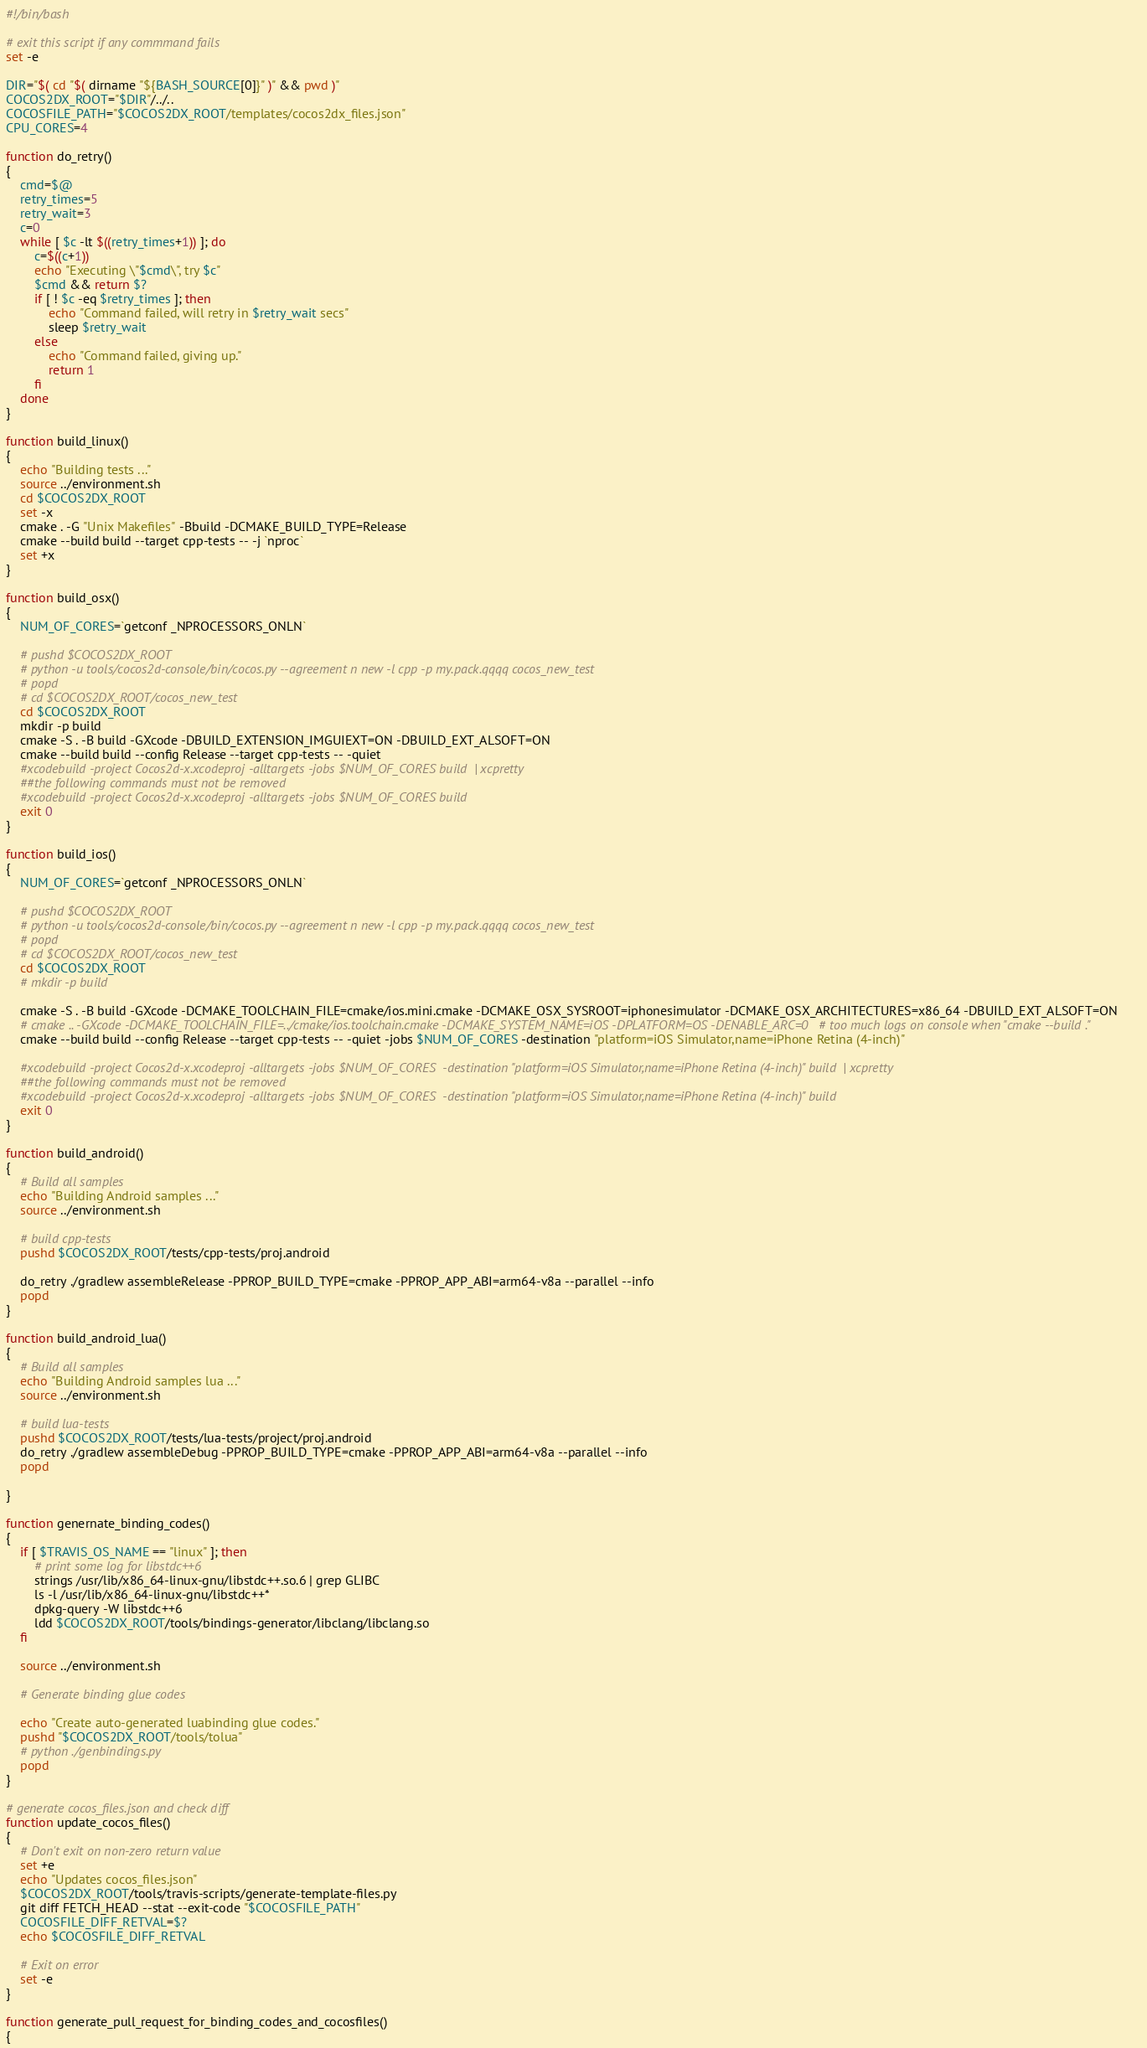<code> <loc_0><loc_0><loc_500><loc_500><_Bash_>#!/bin/bash

# exit this script if any commmand fails
set -e

DIR="$( cd "$( dirname "${BASH_SOURCE[0]}" )" && pwd )"
COCOS2DX_ROOT="$DIR"/../..
COCOSFILE_PATH="$COCOS2DX_ROOT/templates/cocos2dx_files.json"
CPU_CORES=4

function do_retry()
{
	cmd=$@
	retry_times=5
	retry_wait=3
	c=0
	while [ $c -lt $((retry_times+1)) ]; do
		c=$((c+1))
		echo "Executing \"$cmd\", try $c"
		$cmd && return $?
		if [ ! $c -eq $retry_times ]; then
			echo "Command failed, will retry in $retry_wait secs"
			sleep $retry_wait
		else
			echo "Command failed, giving up."
			return 1
		fi
	done
}

function build_linux()
{
    echo "Building tests ..."
    source ../environment.sh
    cd $COCOS2DX_ROOT
    set -x
    cmake . -G "Unix Makefiles" -Bbuild -DCMAKE_BUILD_TYPE=Release
    cmake --build build --target cpp-tests -- -j `nproc`
    set +x
}

function build_osx()
{
    NUM_OF_CORES=`getconf _NPROCESSORS_ONLN`

    # pushd $COCOS2DX_ROOT
    # python -u tools/cocos2d-console/bin/cocos.py --agreement n new -l cpp -p my.pack.qqqq cocos_new_test
    # popd
    # cd $COCOS2DX_ROOT/cocos_new_test
    cd $COCOS2DX_ROOT
    mkdir -p build
    cmake -S . -B build -GXcode -DBUILD_EXTENSION_IMGUIEXT=ON -DBUILD_EXT_ALSOFT=ON
    cmake --build build --config Release --target cpp-tests -- -quiet
    #xcodebuild -project Cocos2d-x.xcodeproj -alltargets -jobs $NUM_OF_CORES build  | xcpretty
    ##the following commands must not be removed
    #xcodebuild -project Cocos2d-x.xcodeproj -alltargets -jobs $NUM_OF_CORES build
    exit 0
}

function build_ios()
{
    NUM_OF_CORES=`getconf _NPROCESSORS_ONLN`

    # pushd $COCOS2DX_ROOT
    # python -u tools/cocos2d-console/bin/cocos.py --agreement n new -l cpp -p my.pack.qqqq cocos_new_test
    # popd
    # cd $COCOS2DX_ROOT/cocos_new_test
    cd $COCOS2DX_ROOT
    # mkdir -p build

    cmake -S . -B build -GXcode -DCMAKE_TOOLCHAIN_FILE=cmake/ios.mini.cmake -DCMAKE_OSX_SYSROOT=iphonesimulator -DCMAKE_OSX_ARCHITECTURES=x86_64 -DBUILD_EXT_ALSOFT=ON
    # cmake .. -GXcode -DCMAKE_TOOLCHAIN_FILE=../cmake/ios.toolchain.cmake -DCMAKE_SYSTEM_NAME=iOS -DPLATFORM=OS -DENABLE_ARC=0   # too much logs on console when "cmake --build ."
    cmake --build build --config Release --target cpp-tests -- -quiet -jobs $NUM_OF_CORES -destination "platform=iOS Simulator,name=iPhone Retina (4-inch)" 

    #xcodebuild -project Cocos2d-x.xcodeproj -alltargets -jobs $NUM_OF_CORES  -destination "platform=iOS Simulator,name=iPhone Retina (4-inch)" build  | xcpretty
    ##the following commands must not be removed
    #xcodebuild -project Cocos2d-x.xcodeproj -alltargets -jobs $NUM_OF_CORES  -destination "platform=iOS Simulator,name=iPhone Retina (4-inch)" build
    exit 0
}

function build_android()
{
    # Build all samples
    echo "Building Android samples ..."
    source ../environment.sh

    # build cpp-tests
    pushd $COCOS2DX_ROOT/tests/cpp-tests/proj.android
    
    do_retry ./gradlew assembleRelease -PPROP_BUILD_TYPE=cmake -PPROP_APP_ABI=arm64-v8a --parallel --info
    popd
}

function build_android_lua()
{
    # Build all samples
    echo "Building Android samples lua ..."
    source ../environment.sh

    # build lua-tests
    pushd $COCOS2DX_ROOT/tests/lua-tests/project/proj.android
    do_retry ./gradlew assembleDebug -PPROP_BUILD_TYPE=cmake -PPROP_APP_ABI=arm64-v8a --parallel --info
    popd

}

function genernate_binding_codes()
{
    if [ $TRAVIS_OS_NAME == "linux" ]; then
        # print some log for libstdc++6
        strings /usr/lib/x86_64-linux-gnu/libstdc++.so.6 | grep GLIBC
        ls -l /usr/lib/x86_64-linux-gnu/libstdc++*
        dpkg-query -W libstdc++6
        ldd $COCOS2DX_ROOT/tools/bindings-generator/libclang/libclang.so
    fi

    source ../environment.sh

    # Generate binding glue codes

    echo "Create auto-generated luabinding glue codes."
    pushd "$COCOS2DX_ROOT/tools/tolua"
    # python ./genbindings.py
    popd
}

# generate cocos_files.json and check diff
function update_cocos_files()
{
    # Don't exit on non-zero return value
    set +e
    echo "Updates cocos_files.json"
    $COCOS2DX_ROOT/tools/travis-scripts/generate-template-files.py
    git diff FETCH_HEAD --stat --exit-code "$COCOSFILE_PATH"
    COCOSFILE_DIFF_RETVAL=$?
    echo $COCOSFILE_DIFF_RETVAL

    # Exit on error
    set -e
}

function generate_pull_request_for_binding_codes_and_cocosfiles()
{</code> 